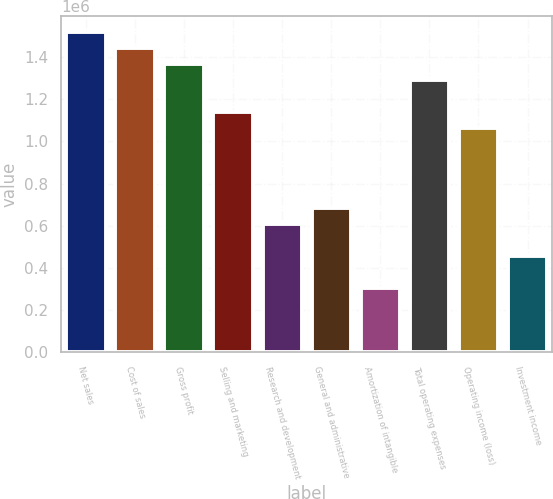Convert chart to OTSL. <chart><loc_0><loc_0><loc_500><loc_500><bar_chart><fcel>Net sales<fcel>Cost of sales<fcel>Gross profit<fcel>Selling and marketing<fcel>Research and development<fcel>General and administrative<fcel>Amortization of intangible<fcel>Total operating expenses<fcel>Operating income (loss)<fcel>Investment income<nl><fcel>1.51905e+06<fcel>1.44309e+06<fcel>1.36714e+06<fcel>1.13929e+06<fcel>607619<fcel>683572<fcel>303810<fcel>1.29119e+06<fcel>1.06333e+06<fcel>455715<nl></chart> 